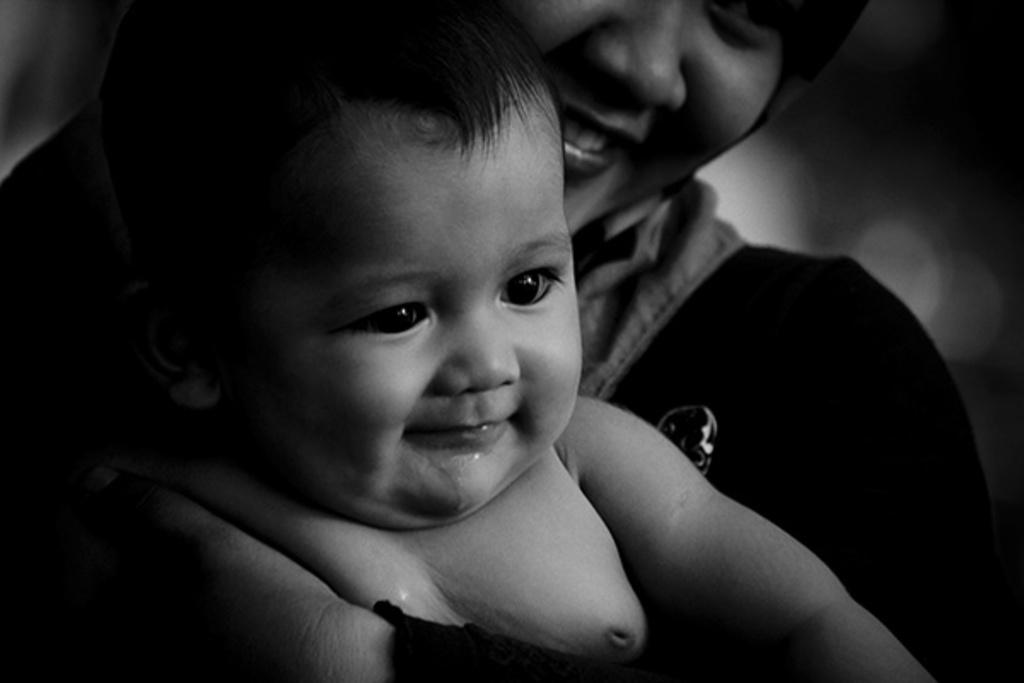What is the color scheme of the image? The image is black and white. What is happening in the image? There is a person holding a baby in the image. Where is the sink located in the image? There is no sink present in the image. Is the person holding the baby in a field? The provided facts do not mention a field, so we cannot determine if the image is set in a field or not. 